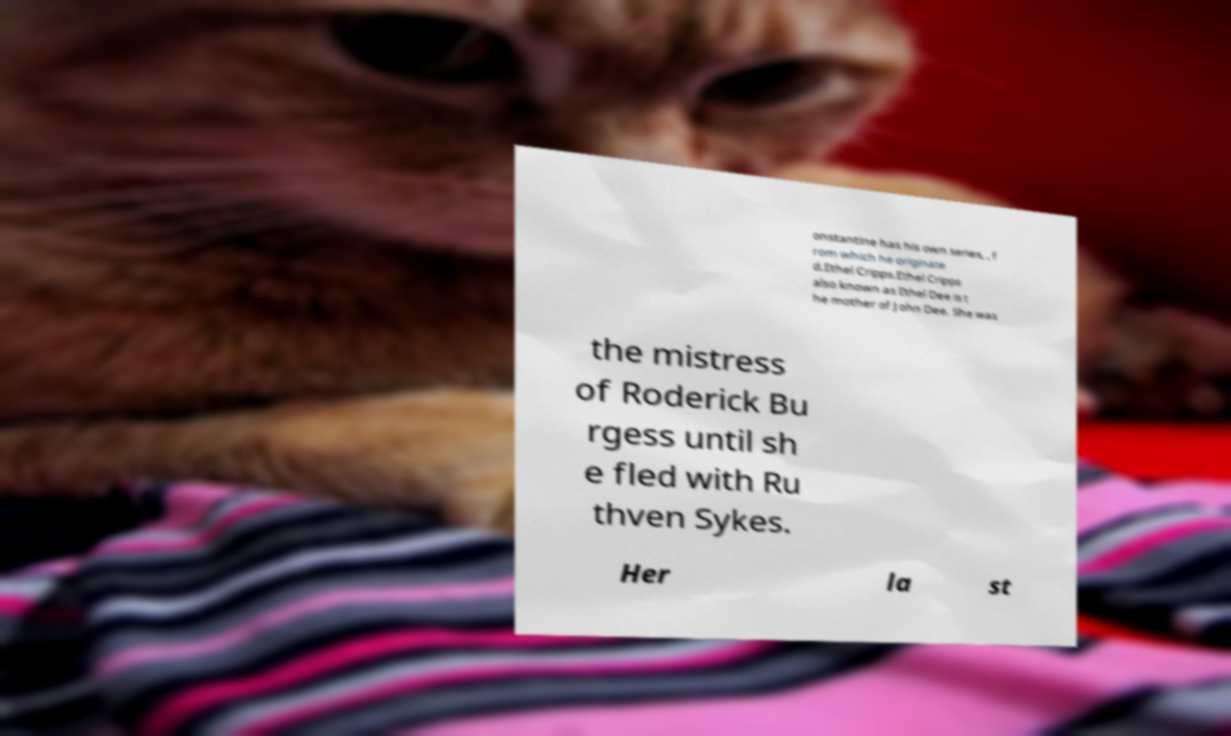There's text embedded in this image that I need extracted. Can you transcribe it verbatim? onstantine has his own series, , f rom which he originate d.Ethel Cripps.Ethel Cripps also known as Ethel Dee is t he mother of John Dee. She was the mistress of Roderick Bu rgess until sh e fled with Ru thven Sykes. Her la st 